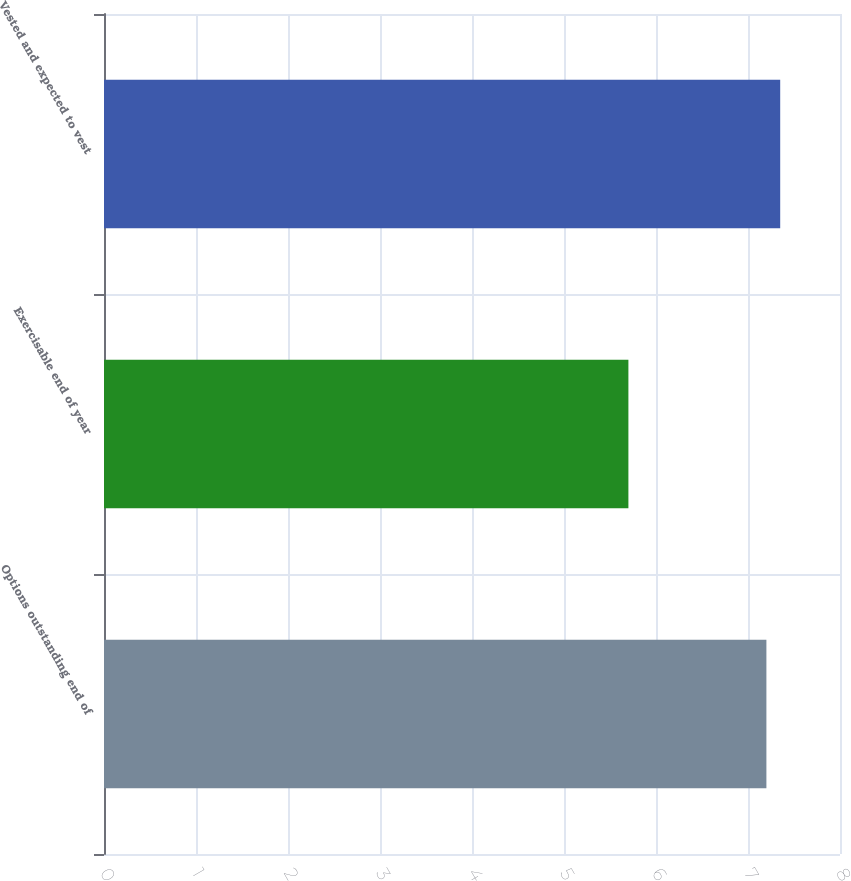<chart> <loc_0><loc_0><loc_500><loc_500><bar_chart><fcel>Options outstanding end of<fcel>Exercisable end of year<fcel>Vested and expected to vest<nl><fcel>7.2<fcel>5.7<fcel>7.35<nl></chart> 